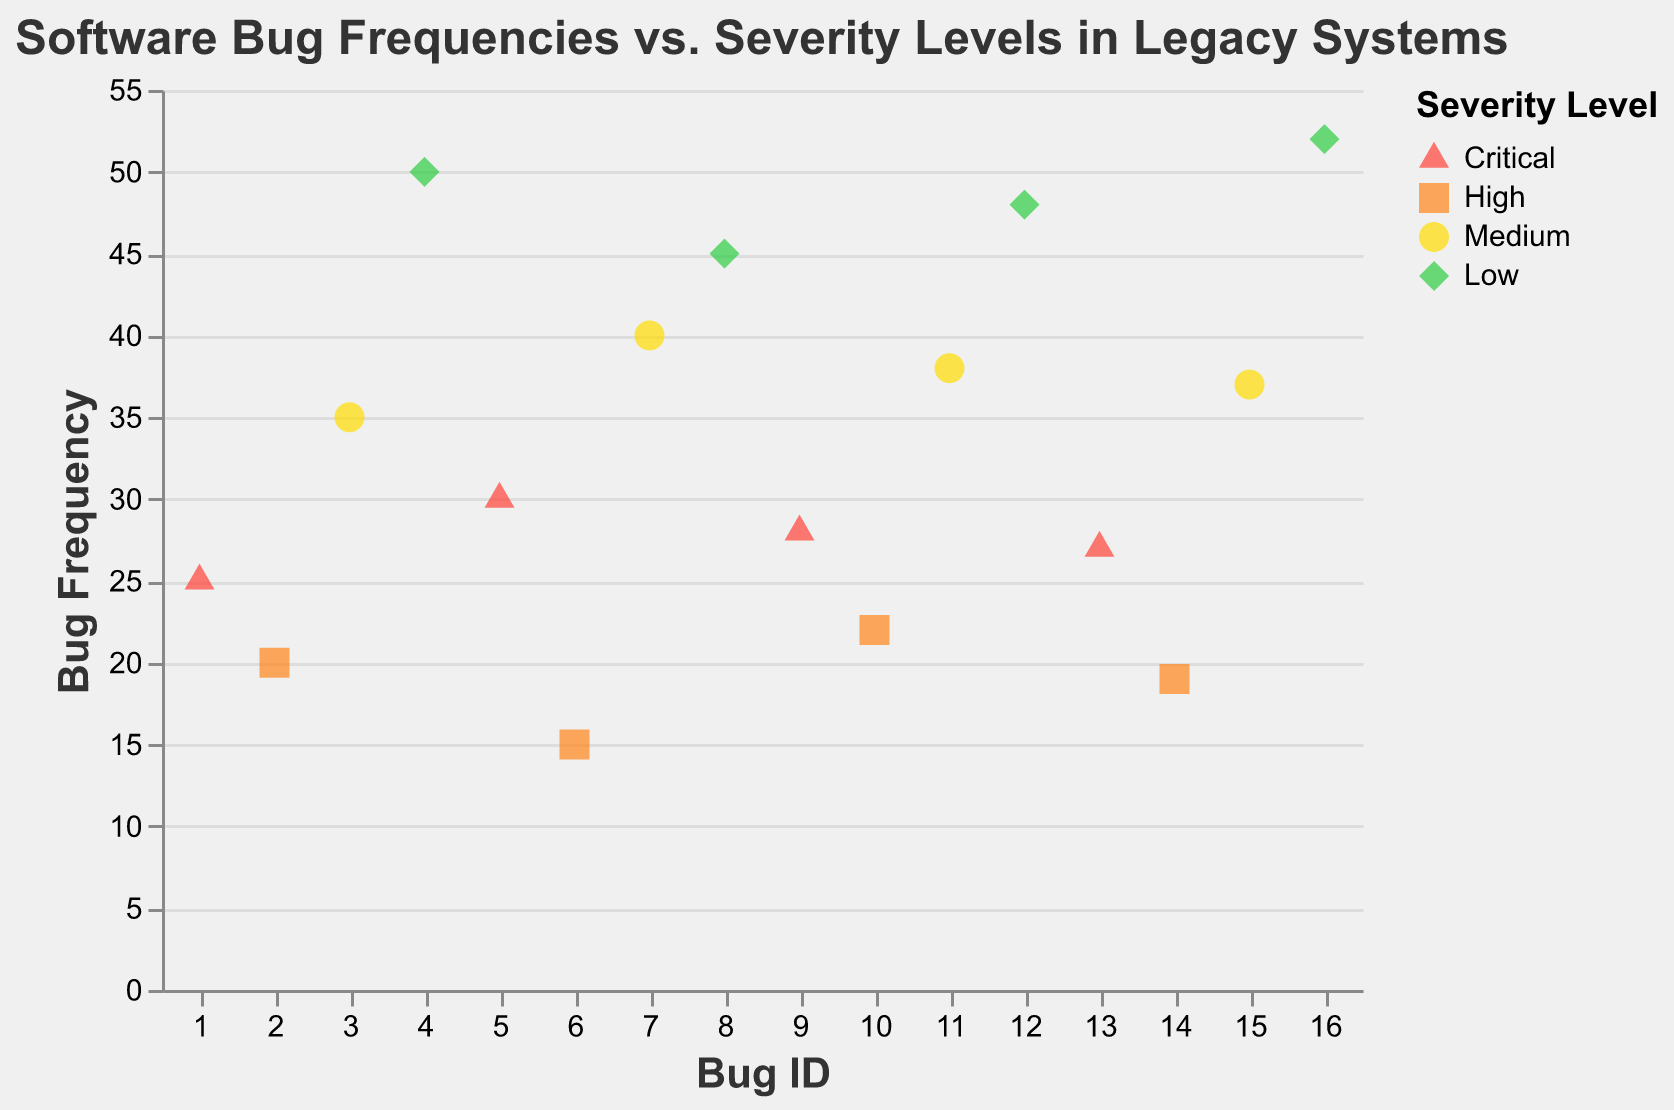What's the title of the scatter plot? The title of the scatter plot is generally located at the top of the plot. From the data, we know that the title specifies what the plot represents.
Answer: Software Bug Frequencies vs. Severity Levels in Legacy Systems Which severity level is represented by the triangle shape? Each severity level in the plot is represented by a different shape. Triangles represent 'Critical' severity levels as indicated by the shape and color legend.
Answer: Critical What is the frequency of the bug with Bug ID 10? To find the frequency of a specific bug, look at the data point corresponding to Bug ID 10 on the x-axis and check its y-axis value. The tooltip might provide additional help.
Answer: 22 What color represents 'Low' severity level? The legend indicates the colors associated with each severity level. Low severity is represented by green.
Answer: Green Which Bug ID has the highest frequency? To determine the highest frequency, look at the highest point on the y-axis and check its corresponding Bug ID on the x-axis.
Answer: 16 Calculate the average frequency of 'Critical' severity level bugs. First, identify all 'Critical' severity level data points (Bug Frequencies of 25, 30, 28, 27). Then sum these values and divide by the number of values. (25 + 30 + 28 + 27) / 4 = 110 / 4 = 27.5
Answer: 27.5 Compare the average frequencies of 'Medium' and 'High' severity level bugs. Which one is higher? Calculate the average Bug Frequency for 'Medium' (35, 40, 38, 37) and 'High' (20, 15, 22, 19) severity levels. For 'Medium': (35 + 40 + 38 + 37) / 4 = 37.5. For 'High': (20 + 15 + 22 + 19) / 4 = 19. The comparison shows 'Medium' has a higher average frequency.
Answer: Medium How many data points have a frequency greater than 30? Scan through the y-axis values and count the number of data points with Bug Frequency greater than 30.
Answer: 7 What shape is associated with 'Medium' severity level? Refer to the shape legend in the scatter plot. 'Medium' severity level is represented by circles.
Answer: Circle Is there more variability in the Bug Frequencies of 'Low' severity level compared to 'High' severity level? Check the range and spread of Bug Frequencies for 'Low' (45, 48, 50, 52) and 'High' (15, 19, 20, 22) severity levels. 'Low' ranges from 45 to 52 while 'High' ranges from 15 to 22. 'Low' has a wider spread and therefore shows more variability.
Answer: Yes 